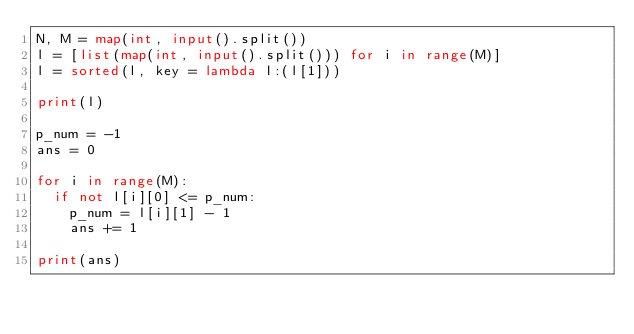<code> <loc_0><loc_0><loc_500><loc_500><_Python_>N, M = map(int, input().split())
l = [list(map(int, input().split())) for i in range(M)]
l = sorted(l, key = lambda l:(l[1]))

print(l)

p_num = -1
ans = 0

for i in range(M):
	if not l[i][0] <= p_num:
		p_num = l[i][1] - 1
		ans += 1

print(ans)</code> 